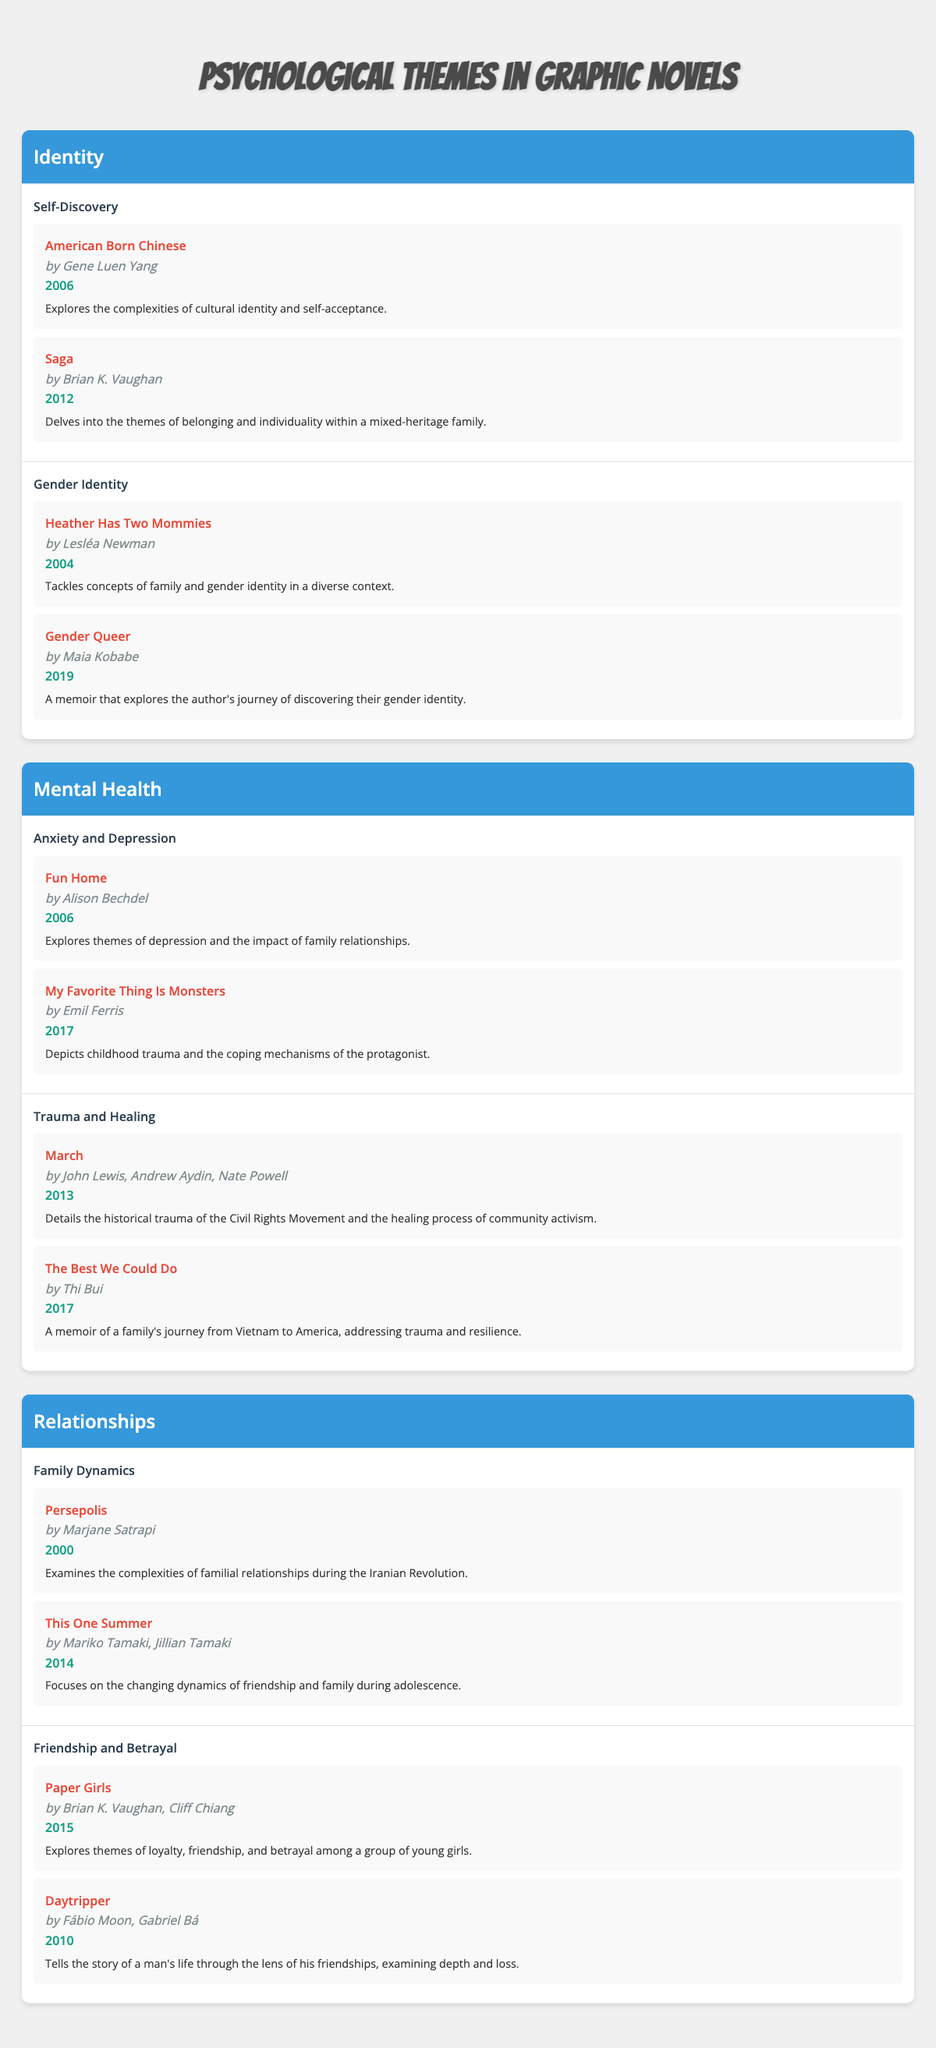What are some examples of graphic novels exploring the theme of anxiety and depression? In the table, under the "Mental Health" theme and the "Anxiety and Depression" sub-theme, the graphic novels listed are "Fun Home" by Alison Bechdel (2006) and "My Favorite Thing Is Monsters" by Emil Ferris (2017)
Answer: "Fun Home" and "My Favorite Thing Is Monsters" What year was "Gender Queer" published? The table shows that "Gender Queer," authored by Maia Kobabe, is listed under the "Gender Identity" sub-theme within the "Identity" category, and it was published in 2019
Answer: 2019 True or False: "Persepolis" explores themes of betrayal. The table classifies "Persepolis" under the "Family Dynamics" sub-theme within the "Relationships" category, focusing on familial relationships, not betrayal, therefore this statement is false
Answer: False Which author has contributed to both the "Family Dynamics" and "Friendship and Betrayal" sub-themes? "Brian K. Vaughan" is listed as the author of "Paper Girls," which falls under "Friendship and Betrayal," and he also wrote "Saga," which is in the "Self-Discovery" sub-theme of "Identity." Thus, he doesn't connect to Family Dynamics based on the available works, indicating no overlap.
Answer: No author connects both sub-themes What is the total number of graphic novels listed under the theme of Relationships? In the "Relationships" theme, there are two sub-themes: "Family Dynamics" with two examples ("Persepolis" and "This One Summer") and "Friendship and Betrayal" with two examples ("Paper Girls" and "Daytripper"). Therefore, the total number of graphic novels is 2 + 2 = 4
Answer: 4 Which graphic novel explores both gender identity and self-acceptance? "Gender Queer," authored by Maia Kobabe, focuses on gender identity. Self-acceptance is a central theme in "American Born Chinese" by Gene Luen Yang, which highlights cultural identity. There isn’t one specific novel listed that captures both well within the examples provided; hence, these themes are explored separately in different novels.
Answer: None What are the sub-themes under the theme of Mental Health? The table outlines two sub-themes under "Mental Health": "Anxiety and Depression" and "Trauma and Healing." These encompass a range of narratives focusing on different aspects of mental health
Answer: Anxiety and Depression, Trauma and Healing How many unique authors are mentioned in the "Identity" theme? Within the "Identity" theme, the authors are Gene Luen Yang ("American Born Chinese"), Brian K. Vaughan ("Saga"), Lesléa Newman ("Heather Has Two Mommies"), and Maia Kobabe ("Gender Queer"). Counting these gives a total of four unique authors
Answer: 4 